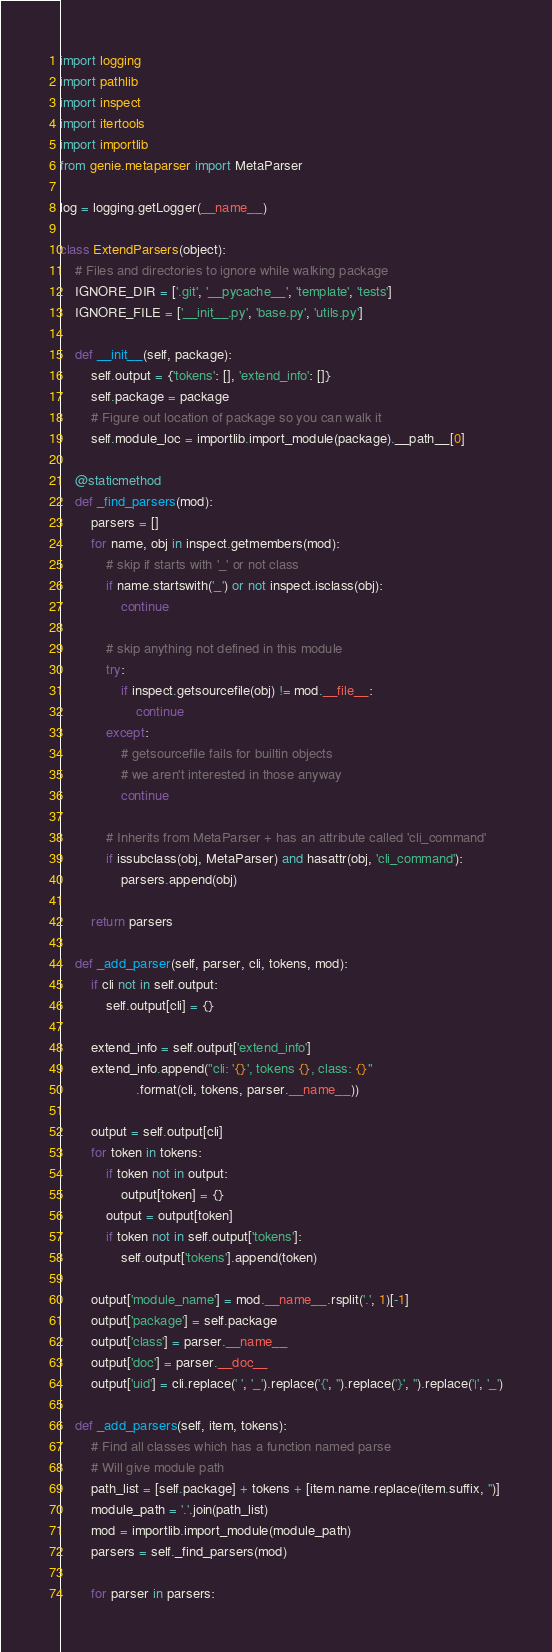Convert code to text. <code><loc_0><loc_0><loc_500><loc_500><_Python_>import logging
import pathlib
import inspect
import itertools
import importlib
from genie.metaparser import MetaParser

log = logging.getLogger(__name__)

class ExtendParsers(object):
    # Files and directories to ignore while walking package
    IGNORE_DIR = ['.git', '__pycache__', 'template', 'tests']
    IGNORE_FILE = ['__init__.py', 'base.py', 'utils.py']

    def __init__(self, package):
        self.output = {'tokens': [], 'extend_info': []}
        self.package = package
        # Figure out location of package so you can walk it
        self.module_loc = importlib.import_module(package).__path__[0]

    @staticmethod
    def _find_parsers(mod):
        parsers = []
        for name, obj in inspect.getmembers(mod):
            # skip if starts with '_' or not class
            if name.startswith('_') or not inspect.isclass(obj):
                continue

            # skip anything not defined in this module
            try:
                if inspect.getsourcefile(obj) != mod.__file__:
                    continue
            except:
                # getsourcefile fails for builtin objects
                # we aren't interested in those anyway
                continue

            # Inherits from MetaParser + has an attribute called 'cli_command'
            if issubclass(obj, MetaParser) and hasattr(obj, 'cli_command'):
                parsers.append(obj)

        return parsers

    def _add_parser(self, parser, cli, tokens, mod):
        if cli not in self.output:
            self.output[cli] = {}

        extend_info = self.output['extend_info']
        extend_info.append("cli: '{}', tokens {}, class: {}"
                    .format(cli, tokens, parser.__name__))

        output = self.output[cli]
        for token in tokens:
            if token not in output:
                output[token] = {}
            output = output[token]
            if token not in self.output['tokens']:
                self.output['tokens'].append(token)

        output['module_name'] = mod.__name__.rsplit('.', 1)[-1]
        output['package'] = self.package
        output['class'] = parser.__name__
        output['doc'] = parser.__doc__
        output['uid'] = cli.replace(' ', '_').replace('{', '').replace('}', '').replace('|', '_')

    def _add_parsers(self, item, tokens):
        # Find all classes which has a function named parse
        # Will give module path
        path_list = [self.package] + tokens + [item.name.replace(item.suffix, '')]
        module_path = '.'.join(path_list)
        mod = importlib.import_module(module_path)
        parsers = self._find_parsers(mod)

        for parser in parsers:</code> 